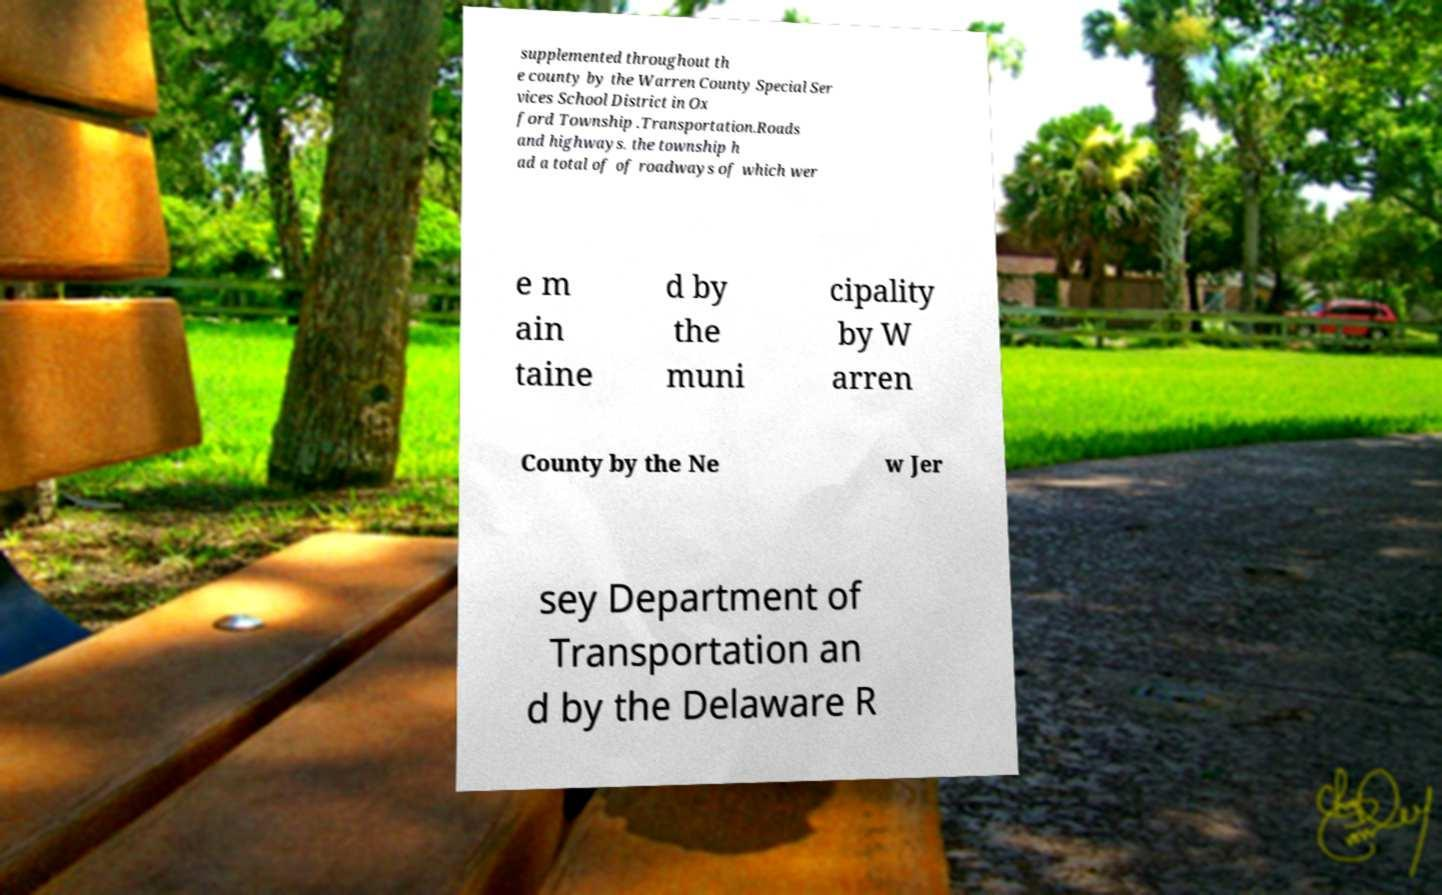Please identify and transcribe the text found in this image. supplemented throughout th e county by the Warren County Special Ser vices School District in Ox ford Township .Transportation.Roads and highways. the township h ad a total of of roadways of which wer e m ain taine d by the muni cipality by W arren County by the Ne w Jer sey Department of Transportation an d by the Delaware R 